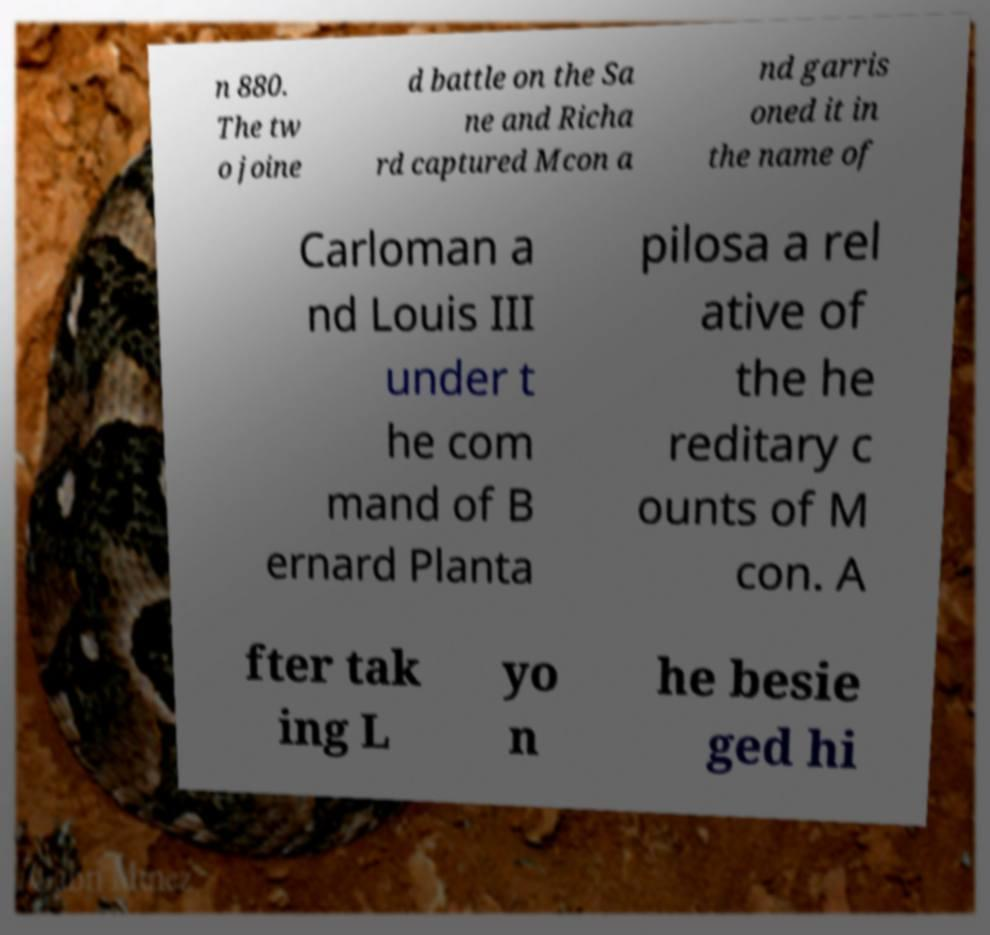Can you accurately transcribe the text from the provided image for me? n 880. The tw o joine d battle on the Sa ne and Richa rd captured Mcon a nd garris oned it in the name of Carloman a nd Louis III under t he com mand of B ernard Planta pilosa a rel ative of the he reditary c ounts of M con. A fter tak ing L yo n he besie ged hi 